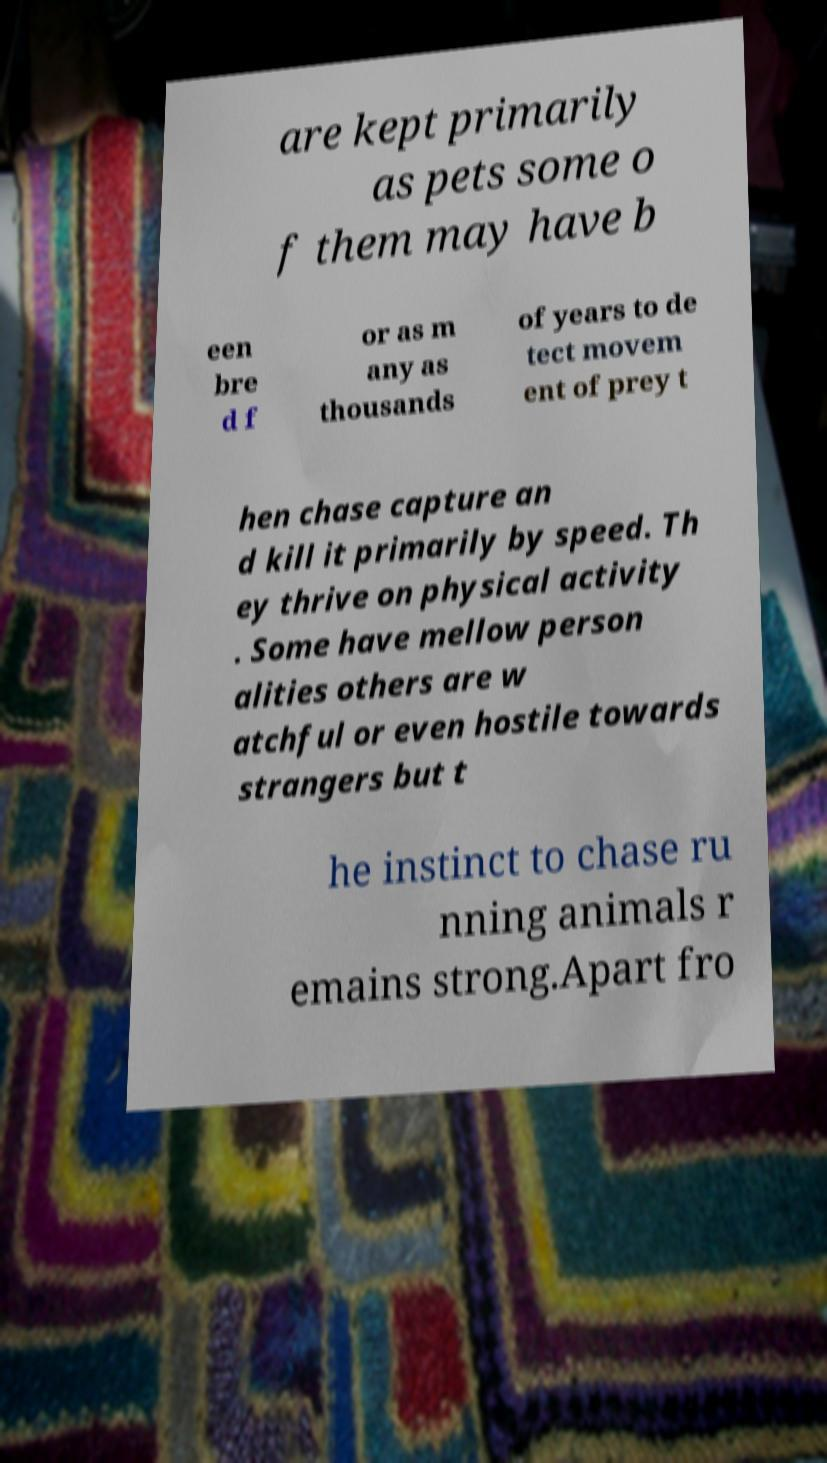There's text embedded in this image that I need extracted. Can you transcribe it verbatim? are kept primarily as pets some o f them may have b een bre d f or as m any as thousands of years to de tect movem ent of prey t hen chase capture an d kill it primarily by speed. Th ey thrive on physical activity . Some have mellow person alities others are w atchful or even hostile towards strangers but t he instinct to chase ru nning animals r emains strong.Apart fro 